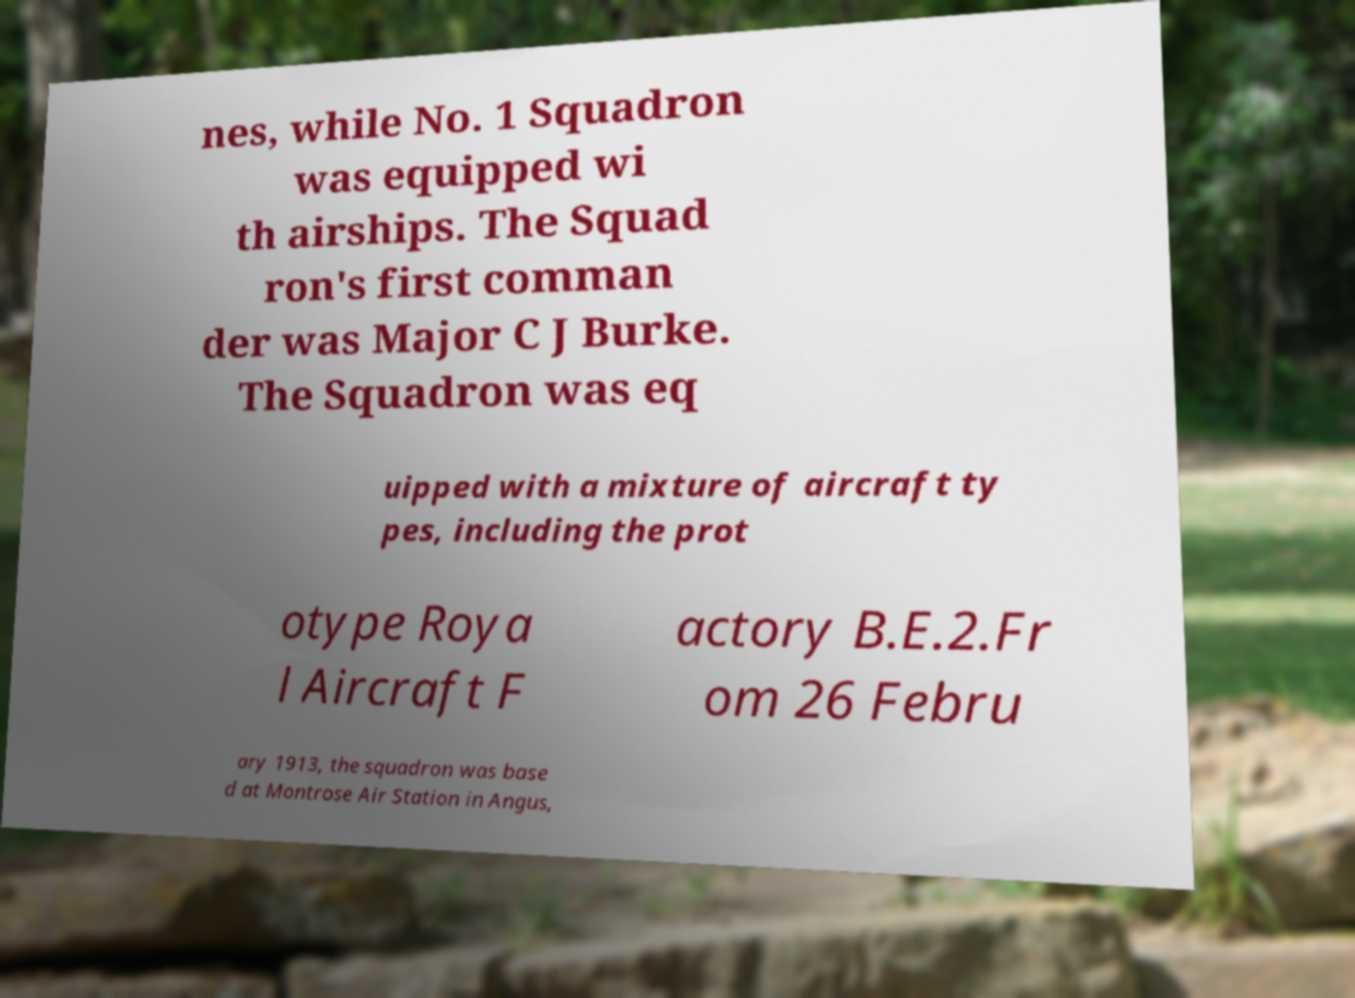There's text embedded in this image that I need extracted. Can you transcribe it verbatim? nes, while No. 1 Squadron was equipped wi th airships. The Squad ron's first comman der was Major C J Burke. The Squadron was eq uipped with a mixture of aircraft ty pes, including the prot otype Roya l Aircraft F actory B.E.2.Fr om 26 Febru ary 1913, the squadron was base d at Montrose Air Station in Angus, 